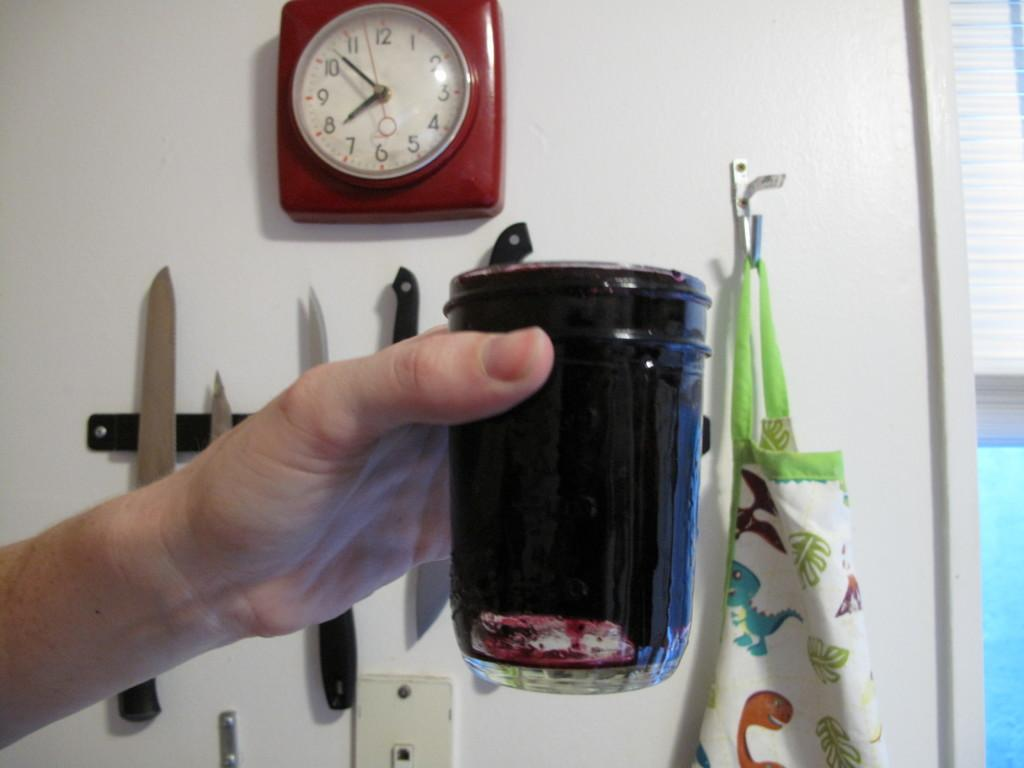<image>
Share a concise interpretation of the image provided. a cup and a clock in the back with 1 to 12 on it 